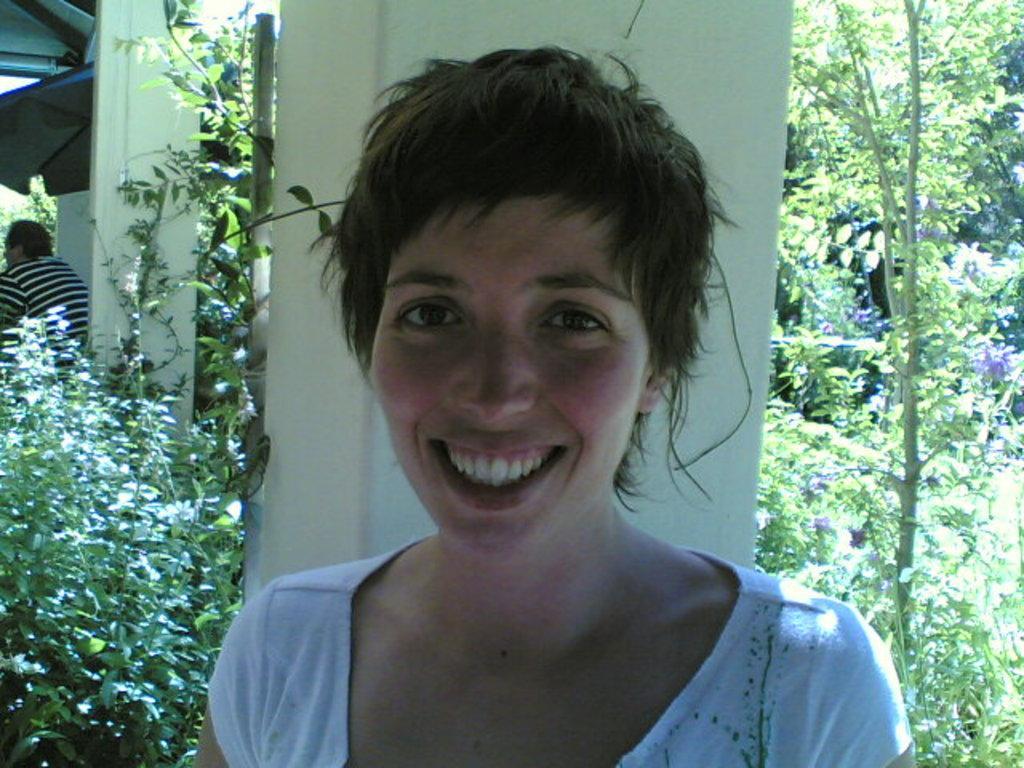In one or two sentences, can you explain what this image depicts? In this picture we can see a woman smiling, pillars, roof top, trees and a person. 